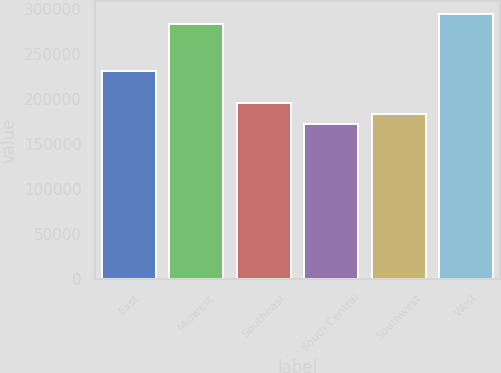Convert chart. <chart><loc_0><loc_0><loc_500><loc_500><bar_chart><fcel>East<fcel>Midwest<fcel>Southeast<fcel>South Central<fcel>Southwest<fcel>West<nl><fcel>231400<fcel>283300<fcel>195280<fcel>172700<fcel>183990<fcel>294590<nl></chart> 